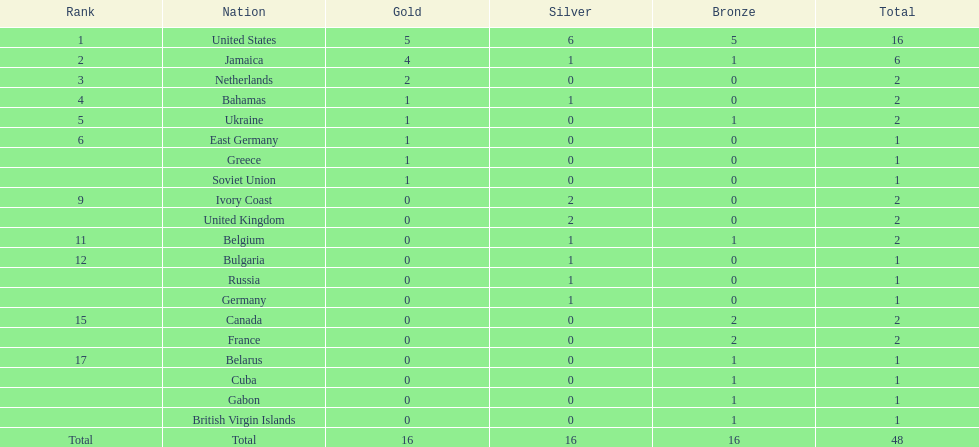How many nations won more than one silver medal? 3. 